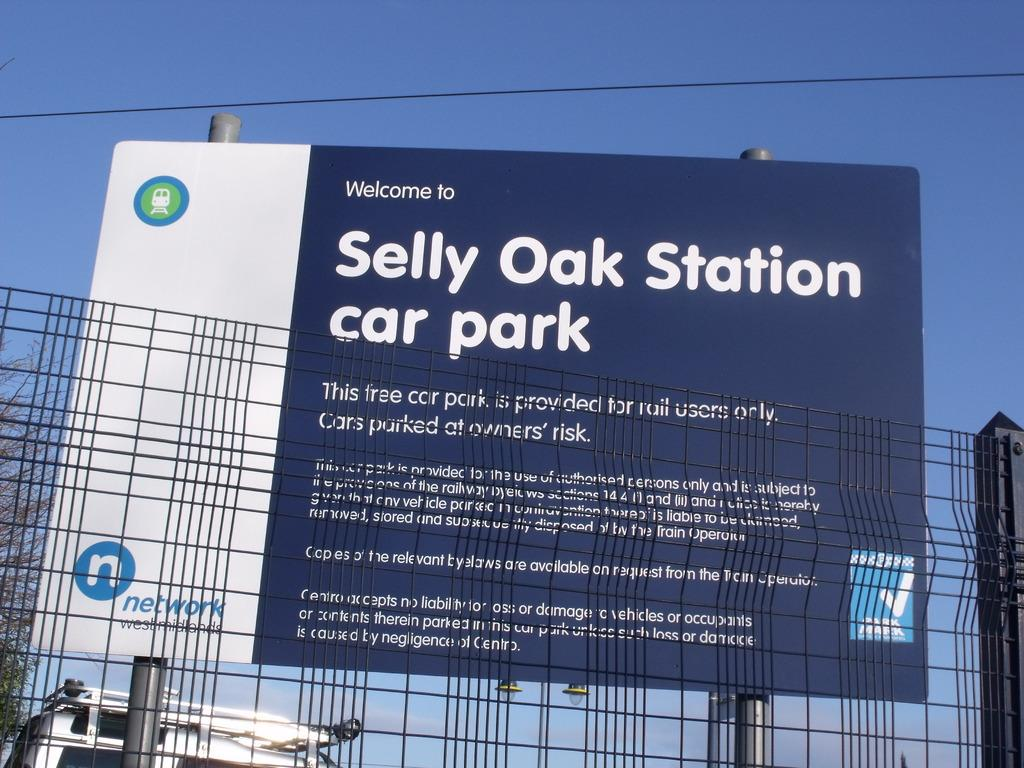<image>
Give a short and clear explanation of the subsequent image. A sign behind a fence proclaims welocme to Selly Oak Station Car Park. 